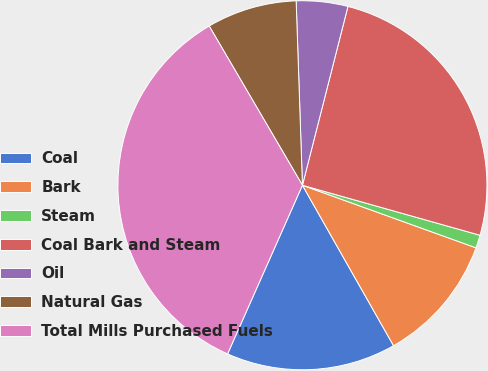Convert chart to OTSL. <chart><loc_0><loc_0><loc_500><loc_500><pie_chart><fcel>Coal<fcel>Bark<fcel>Steam<fcel>Coal Bark and Steam<fcel>Oil<fcel>Natural Gas<fcel>Total Mills Purchased Fuels<nl><fcel>14.87%<fcel>11.27%<fcel>1.14%<fcel>25.4%<fcel>4.51%<fcel>7.89%<fcel>34.92%<nl></chart> 